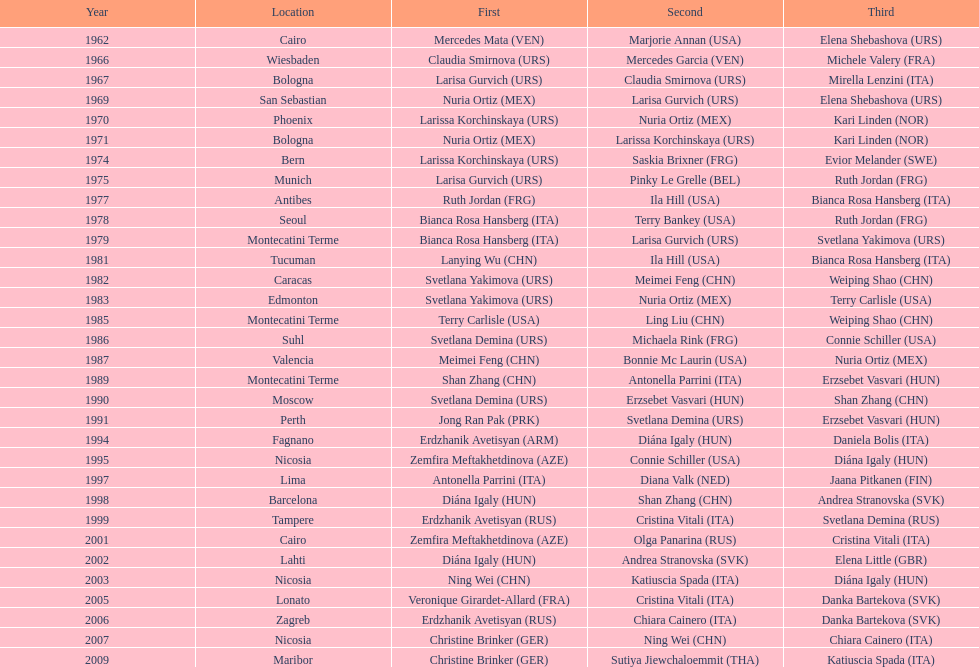Who won the only gold medal in 1962? Mercedes Mata. 